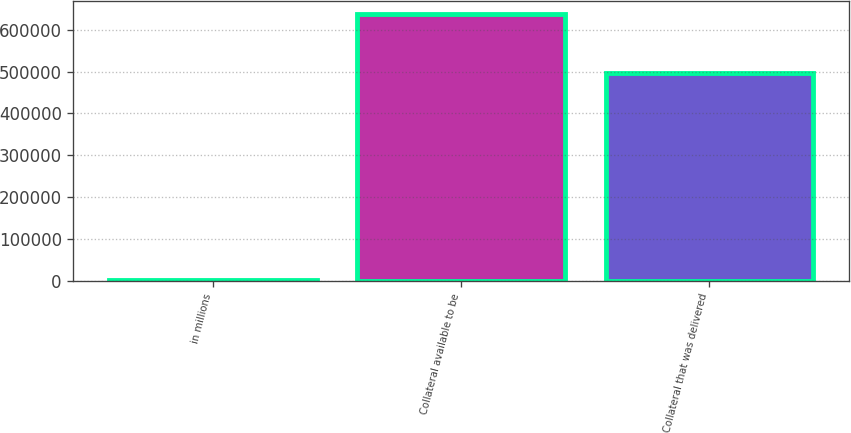<chart> <loc_0><loc_0><loc_500><loc_500><bar_chart><fcel>in millions<fcel>Collateral available to be<fcel>Collateral that was delivered<nl><fcel>2015<fcel>636684<fcel>496240<nl></chart> 